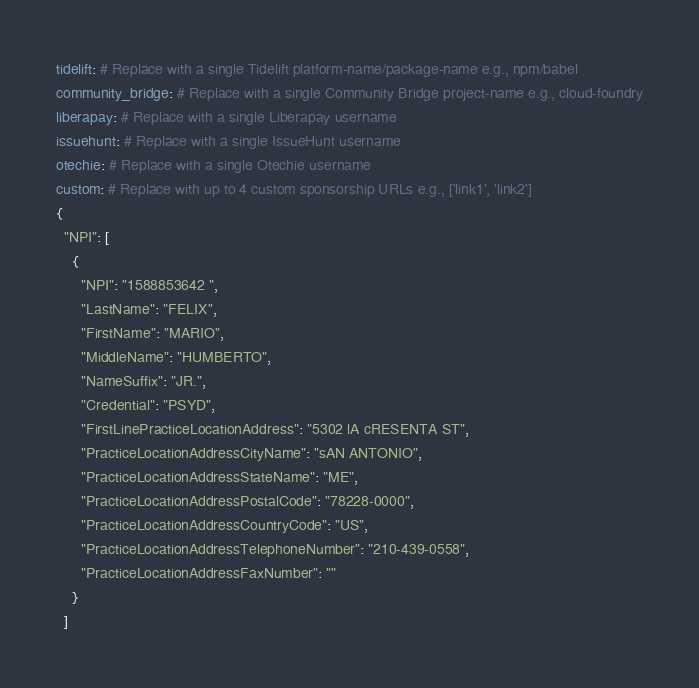<code> <loc_0><loc_0><loc_500><loc_500><_YAML_>tidelift: # Replace with a single Tidelift platform-name/package-name e.g., npm/babel
community_bridge: # Replace with a single Community Bridge project-name e.g., cloud-foundry
liberapay: # Replace with a single Liberapay username
issuehunt: # Replace with a single IssueHunt username
otechie: # Replace with a single Otechie username
custom: # Replace with up to 4 custom sponsorship URLs e.g., ['link1', 'link2']
{
  "NPI": [
    {
      "NPI": "1588853642 ",
      "LastName": "FELIX",
      "FirstName": "MARIO",
      "MiddleName": "HUMBERTO",
      "NameSuffix": "JR.",
      "Credential": "PSYD",
      "FirstLinePracticeLocationAddress": "5302 lA cRESENTA ST",
      "PracticeLocationAddressCityName": "sAN ANTONIO",
      "PracticeLocationAddressStateName": "ME",
      "PracticeLocationAddressPostalCode": "78228-0000",
      "PracticeLocationAddressCountryCode": "US",
      "PracticeLocationAddressTelephoneNumber": "210-439-0558",
      "PracticeLocationAddressFaxNumber": ""
    }
  ]
</code> 